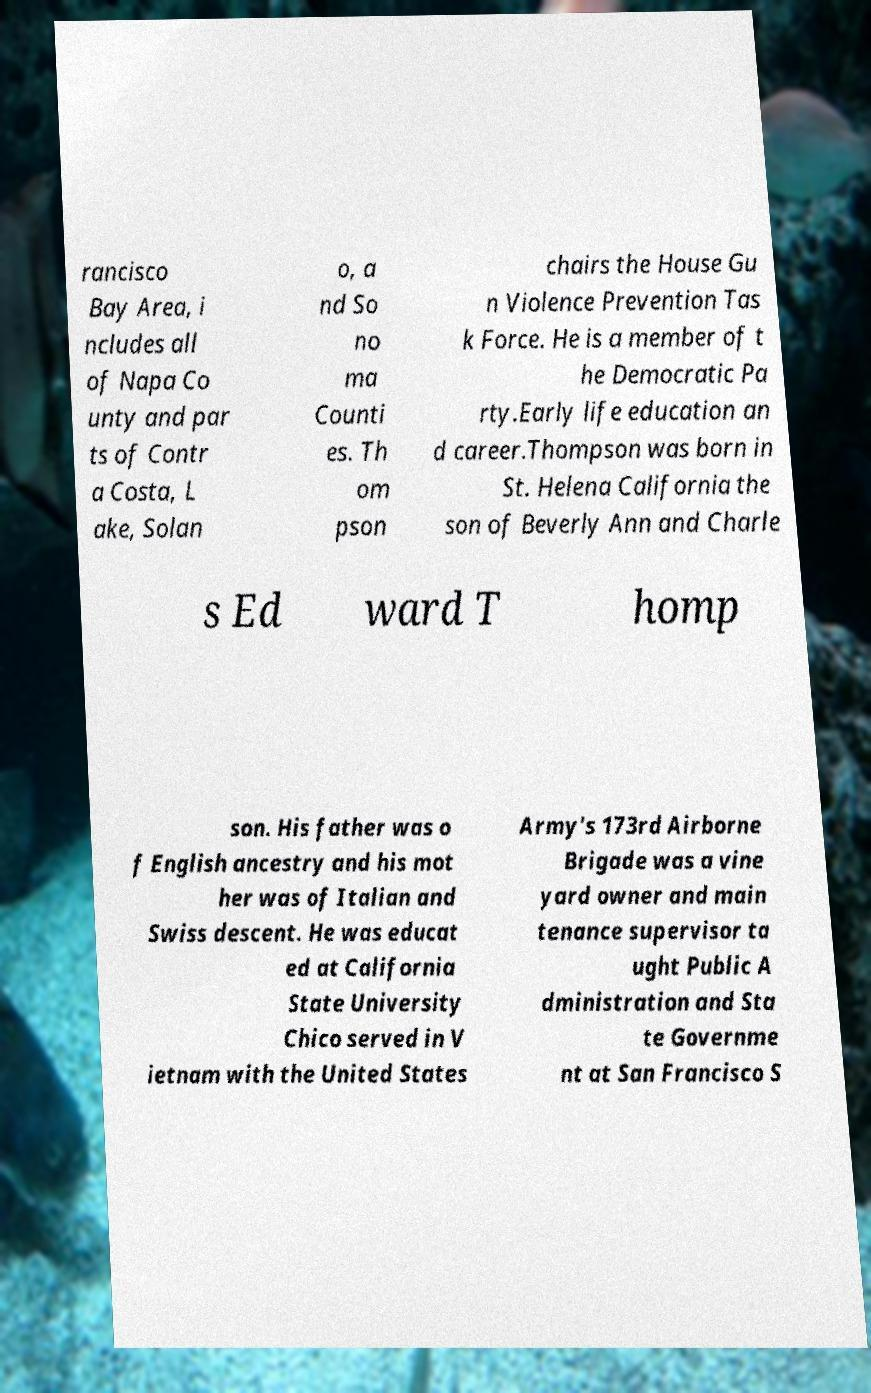What messages or text are displayed in this image? I need them in a readable, typed format. rancisco Bay Area, i ncludes all of Napa Co unty and par ts of Contr a Costa, L ake, Solan o, a nd So no ma Counti es. Th om pson chairs the House Gu n Violence Prevention Tas k Force. He is a member of t he Democratic Pa rty.Early life education an d career.Thompson was born in St. Helena California the son of Beverly Ann and Charle s Ed ward T homp son. His father was o f English ancestry and his mot her was of Italian and Swiss descent. He was educat ed at California State University Chico served in V ietnam with the United States Army's 173rd Airborne Brigade was a vine yard owner and main tenance supervisor ta ught Public A dministration and Sta te Governme nt at San Francisco S 